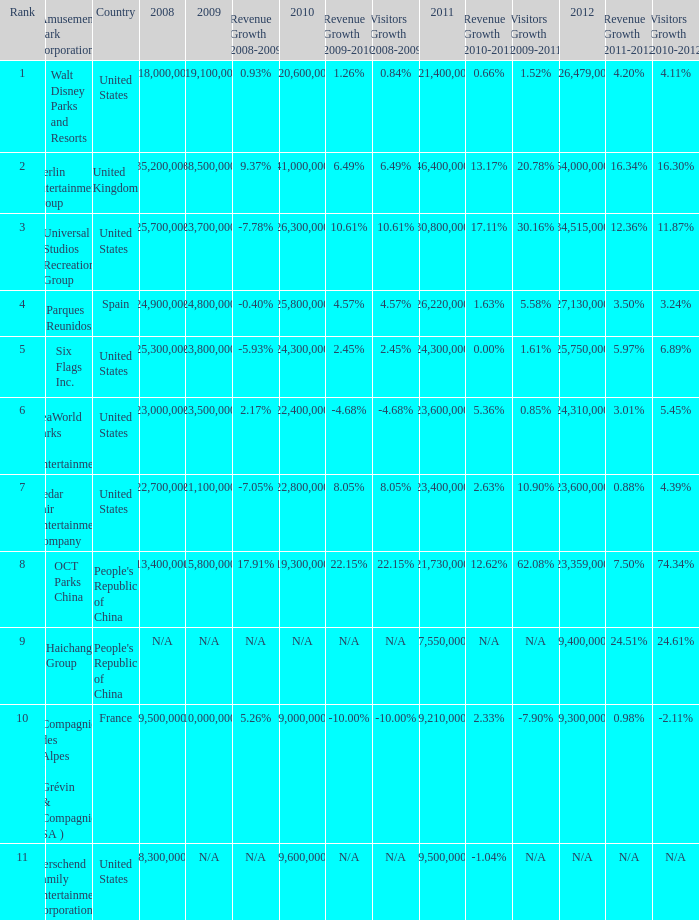What is the Rank listed for the attendance of 2010 of 9,000,000 and 2011 larger than 9,210,000? None. 